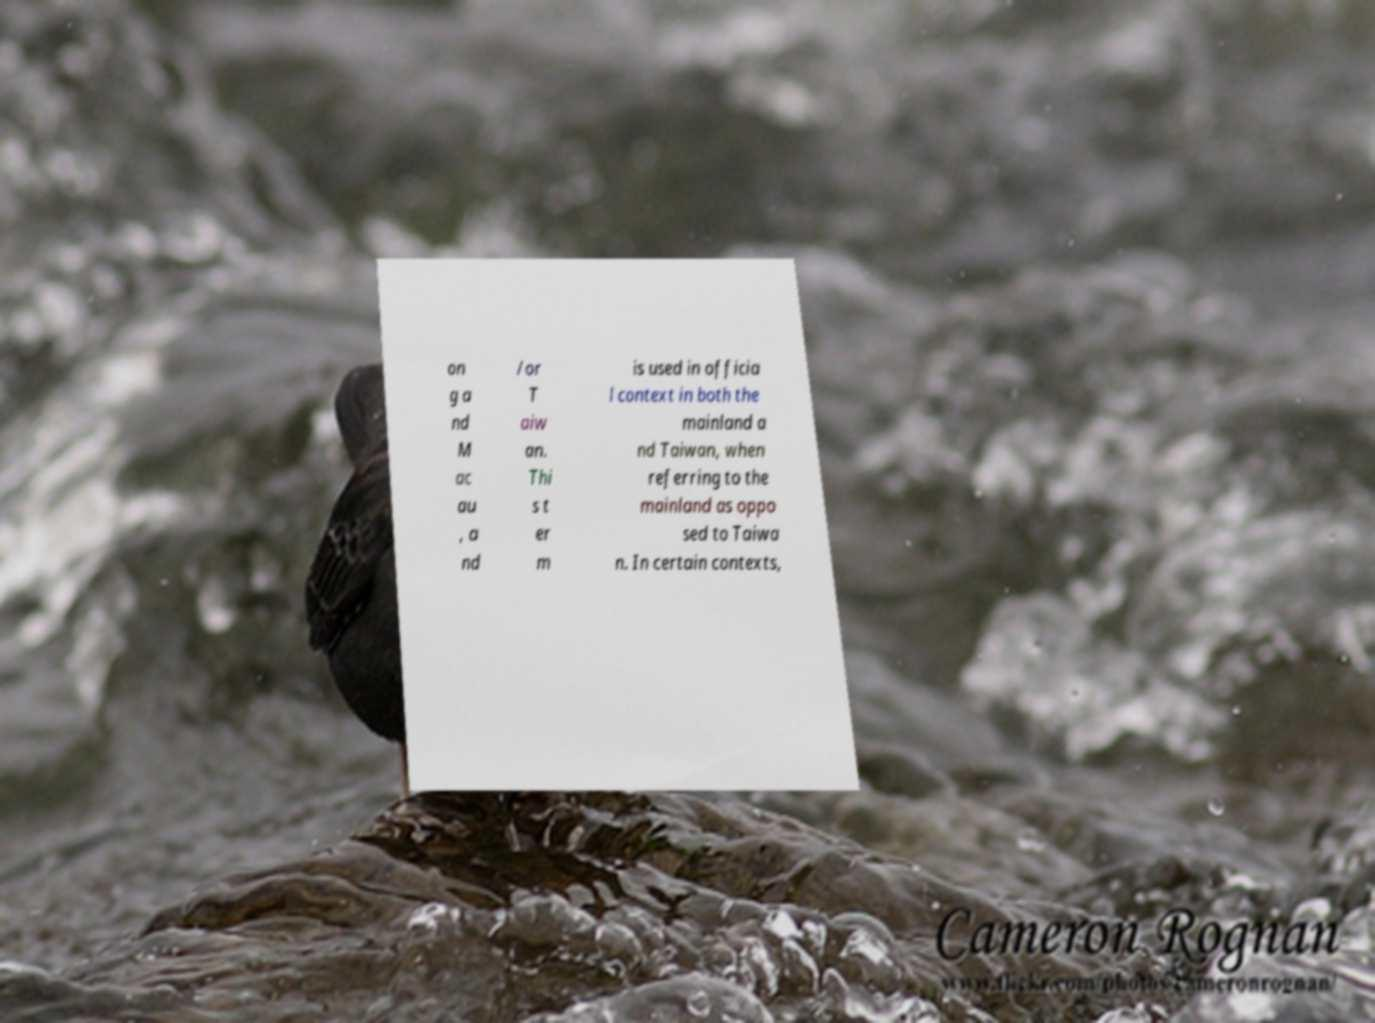Please read and relay the text visible in this image. What does it say? on g a nd M ac au , a nd /or T aiw an. Thi s t er m is used in officia l context in both the mainland a nd Taiwan, when referring to the mainland as oppo sed to Taiwa n. In certain contexts, 